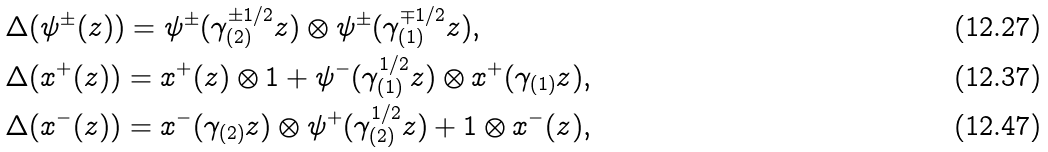Convert formula to latex. <formula><loc_0><loc_0><loc_500><loc_500>& \Delta ( \psi ^ { \pm } ( z ) ) = \psi ^ { \pm } ( \gamma _ { ( 2 ) } ^ { \pm 1 / 2 } z ) \otimes \psi ^ { \pm } ( \gamma _ { ( 1 ) } ^ { \mp 1 / 2 } z ) , \\ & \Delta ( x ^ { + } ( z ) ) = x ^ { + } ( z ) \otimes 1 + \psi ^ { - } ( \gamma _ { ( 1 ) } ^ { 1 / 2 } z ) \otimes x ^ { + } ( \gamma _ { ( 1 ) } z ) , \\ & \Delta ( x ^ { - } ( z ) ) = x ^ { - } ( \gamma _ { ( 2 ) } z ) \otimes \psi ^ { + } ( \gamma _ { ( 2 ) } ^ { 1 / 2 } z ) + 1 \otimes x ^ { - } ( z ) ,</formula> 